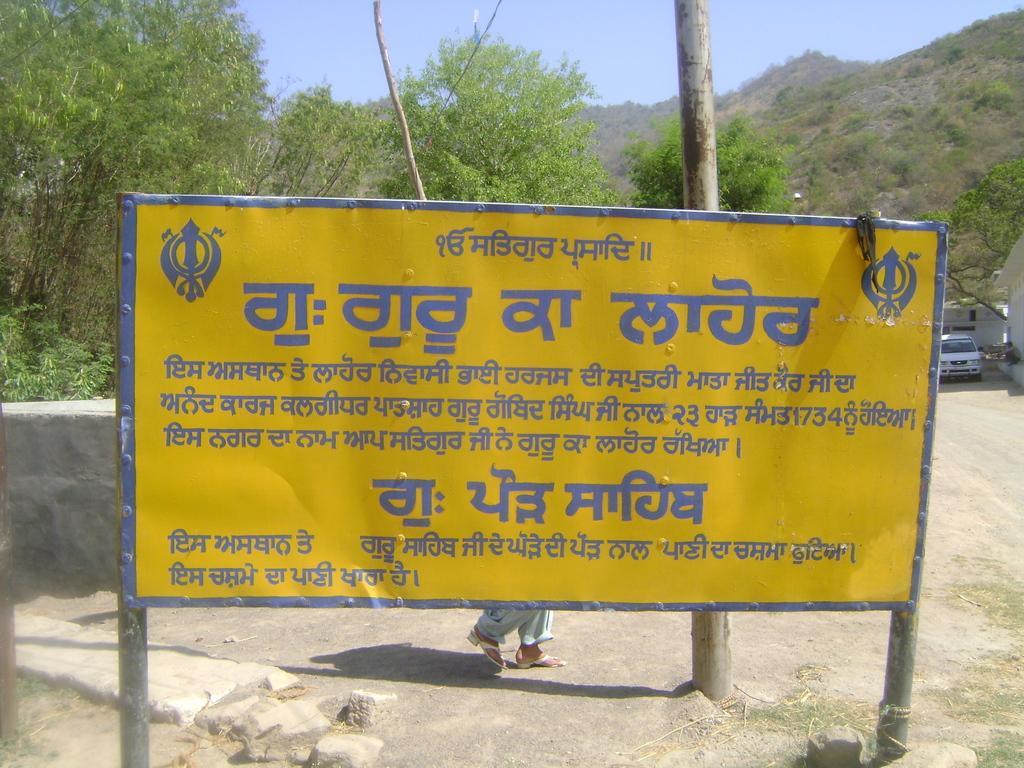In one or two sentences, can you explain what this image depicts? In this image, we can see some trees. There is a board in front of the pole contains some text. There is a car on the right side of the image. There is a hill in the top right of the image. There is a sky at the top of the image. 